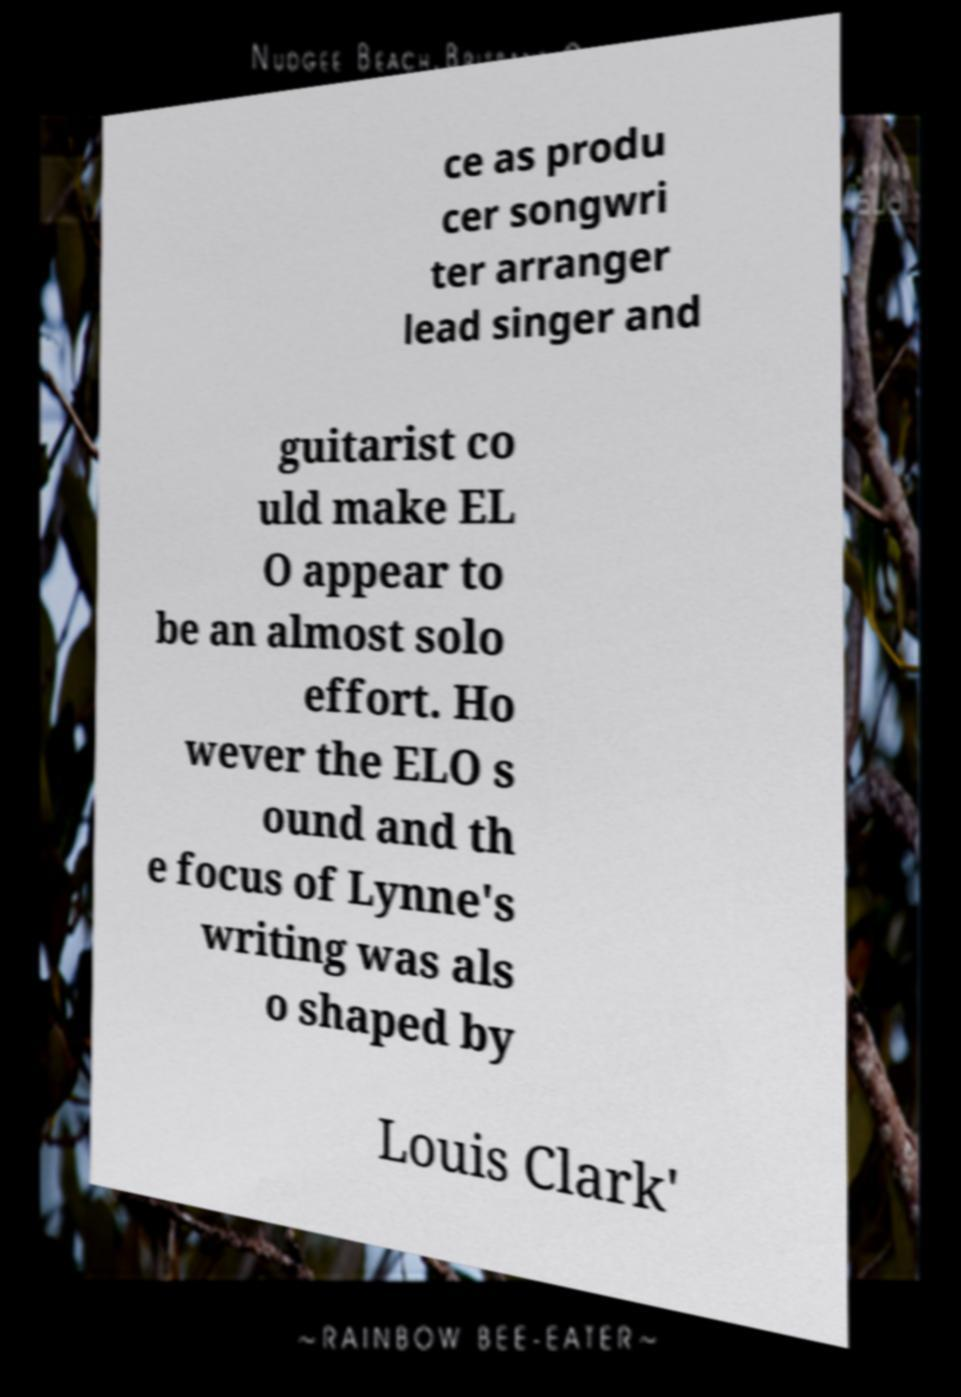Could you assist in decoding the text presented in this image and type it out clearly? ce as produ cer songwri ter arranger lead singer and guitarist co uld make EL O appear to be an almost solo effort. Ho wever the ELO s ound and th e focus of Lynne's writing was als o shaped by Louis Clark' 